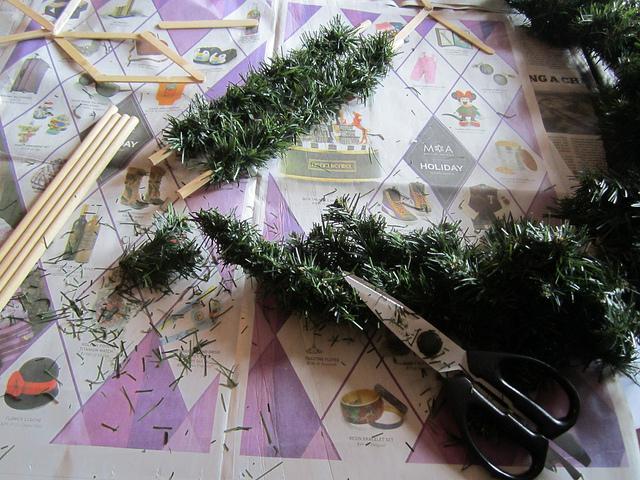Is the vine real?
Keep it brief. No. How many pairs of scissors are shown in this picture?
Give a very brief answer. 1. Do you see any popsicle sticks?
Give a very brief answer. Yes. 